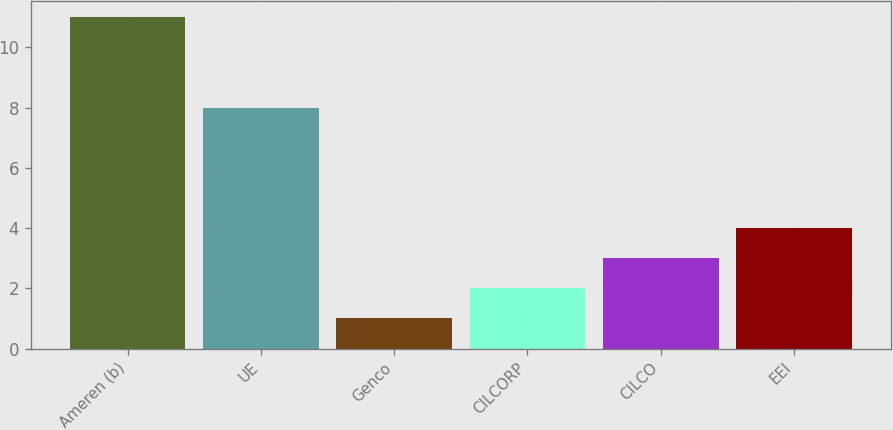Convert chart. <chart><loc_0><loc_0><loc_500><loc_500><bar_chart><fcel>Ameren (b)<fcel>UE<fcel>Genco<fcel>CILCORP<fcel>CILCO<fcel>EEI<nl><fcel>11<fcel>8<fcel>1<fcel>2<fcel>3<fcel>4<nl></chart> 